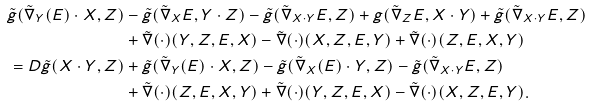<formula> <loc_0><loc_0><loc_500><loc_500>\tilde { g } ( \tilde { \nabla } _ { Y } ( E ) \cdot X , Z ) & - \tilde { g } ( \tilde { \nabla } _ { X } E , Y \cdot Z ) - \tilde { g } ( \tilde { \nabla } _ { X \cdot Y } E , Z ) + { g } ( \tilde { \nabla } _ { Z } E , X \cdot Y ) + \tilde { g } ( \tilde { \nabla } _ { X \cdot Y } E , Z ) \\ & + \tilde { \nabla } ( \cdot ) ( Y , Z , E , X ) - \tilde { \nabla } ( \cdot ) ( X , Z , E , Y ) + \tilde { \nabla } ( \cdot ) ( Z , E , X , Y ) \\ = D \tilde { g } ( X \cdot Y , Z ) & + \tilde { g } ( \tilde { \nabla } _ { Y } ( E ) \cdot X , Z ) - \tilde { g } ( \tilde { \nabla } _ { X } ( E ) \cdot Y , Z ) - \tilde { g } ( \tilde { \nabla } _ { X \cdot Y } E , Z ) \\ & + \tilde { \nabla } ( \cdot ) ( Z , E , X , Y ) + \tilde { \nabla } ( \cdot ) ( Y , Z , E , X ) - \tilde { \nabla } ( \cdot ) ( X , Z , E , Y ) . \\</formula> 